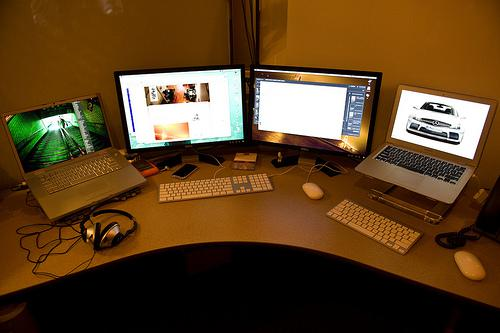Question: what in the picture would be used to type with?
Choices:
A. A typewriter.
B. A phone.
C. A tablet.
D. Keyboard.
Answer with the letter. Answer: D Question: how many screens are in the picture?
Choices:
A. Two.
B. Three.
C. Five.
D. Four.
Answer with the letter. Answer: D Question: where is the car?
Choices:
A. In the road.
B. In the parking garage.
C. In the driveway.
D. On a screen.
Answer with the letter. Answer: D 